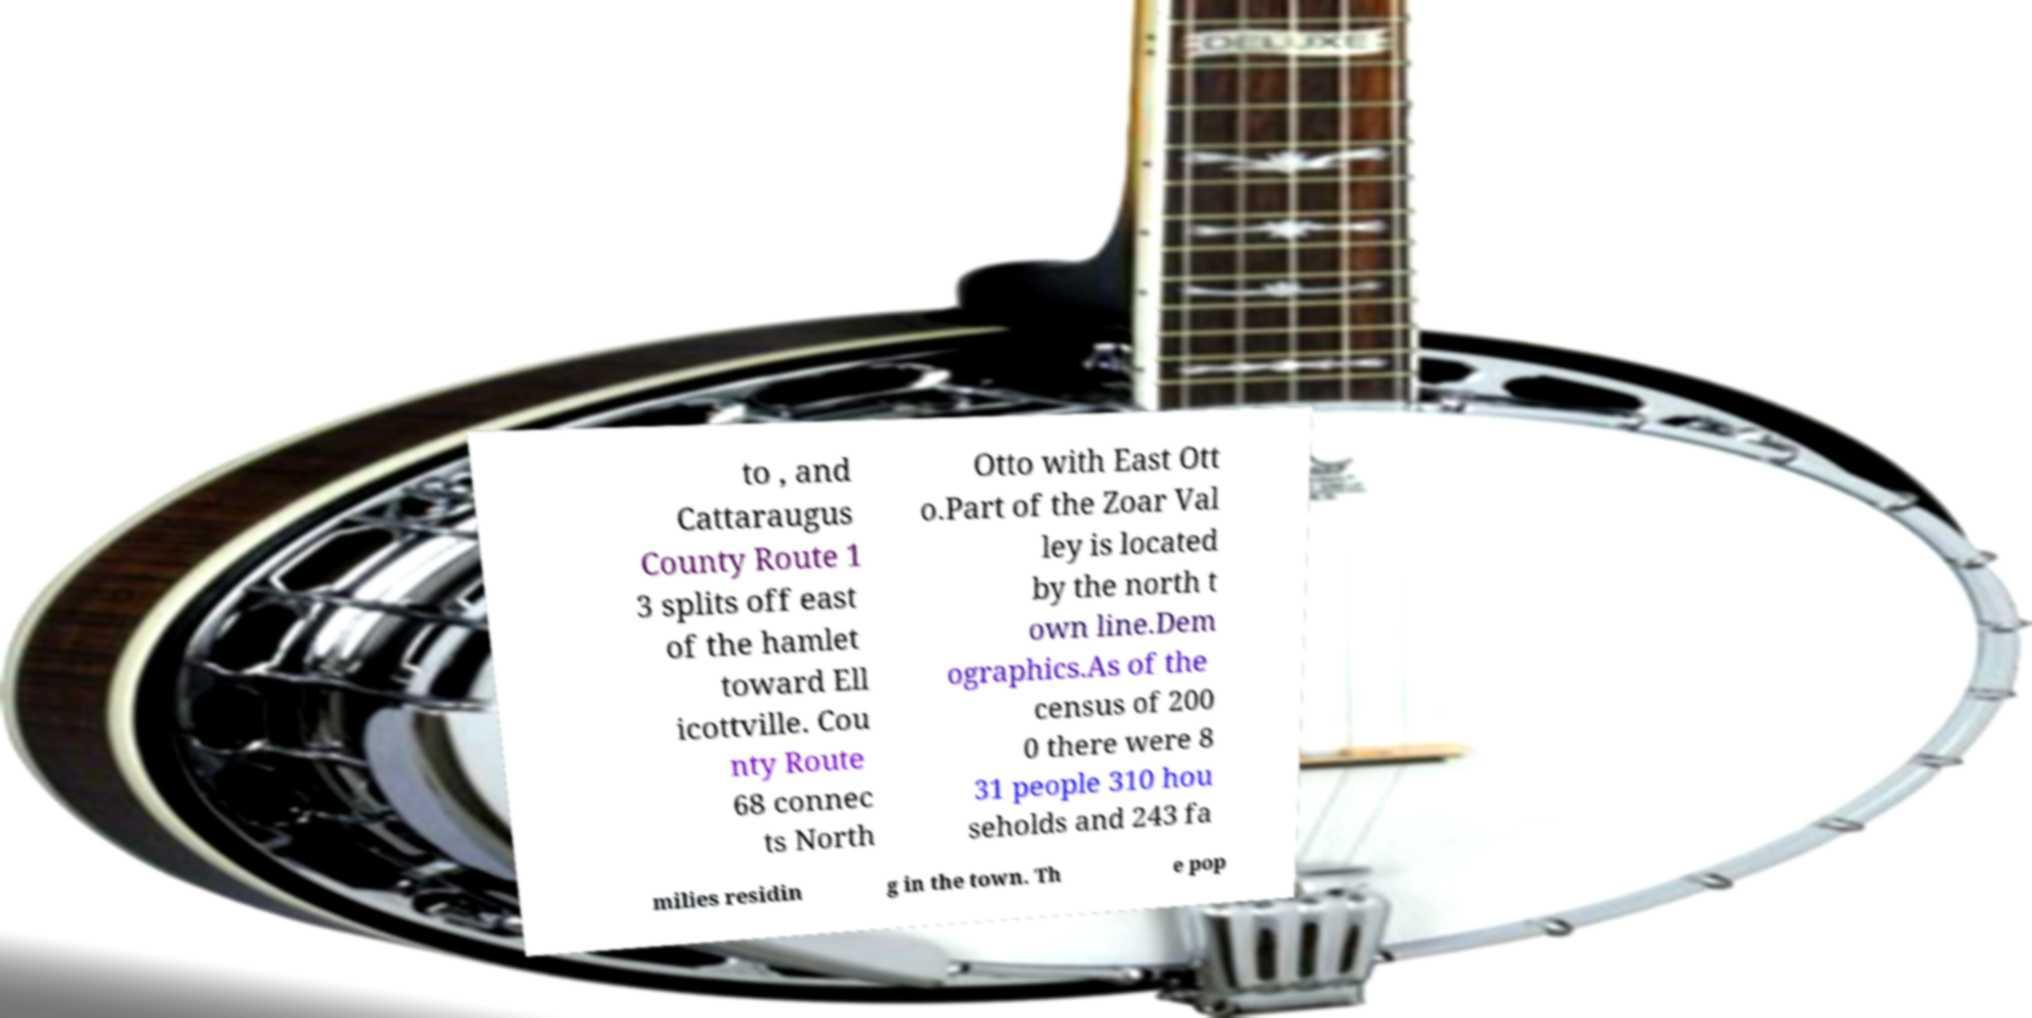For documentation purposes, I need the text within this image transcribed. Could you provide that? to , and Cattaraugus County Route 1 3 splits off east of the hamlet toward Ell icottville. Cou nty Route 68 connec ts North Otto with East Ott o.Part of the Zoar Val ley is located by the north t own line.Dem ographics.As of the census of 200 0 there were 8 31 people 310 hou seholds and 243 fa milies residin g in the town. Th e pop 